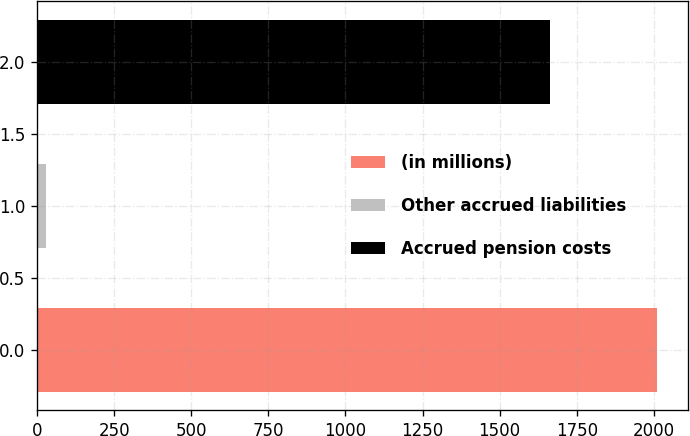Convert chart. <chart><loc_0><loc_0><loc_500><loc_500><bar_chart><fcel>(in millions)<fcel>Other accrued liabilities<fcel>Accrued pension costs<nl><fcel>2011<fcel>28<fcel>1662<nl></chart> 